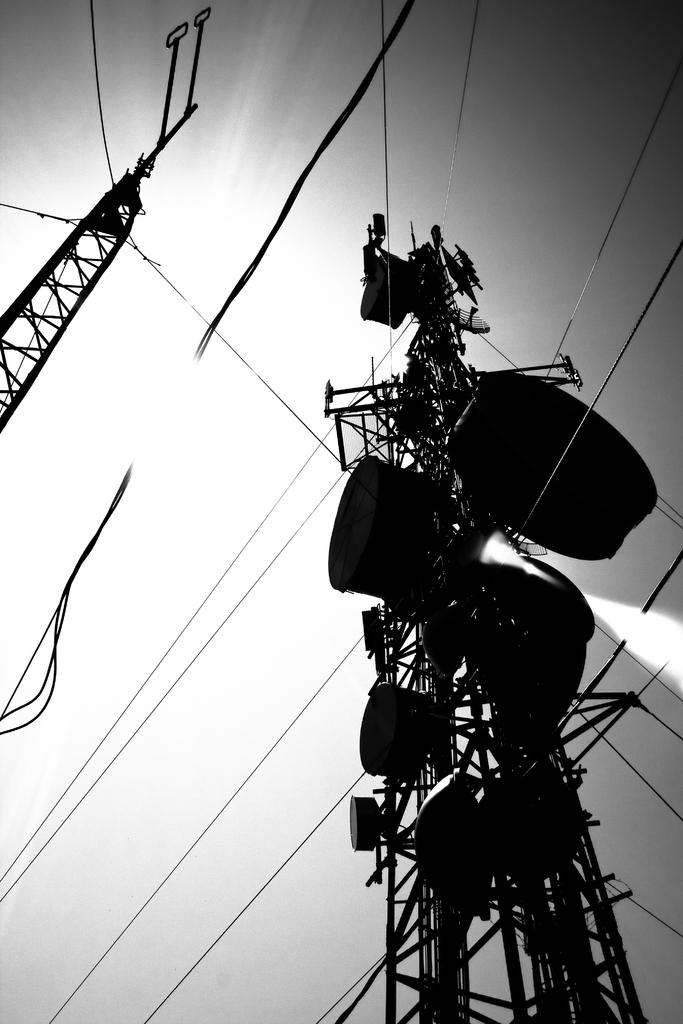What is the color scheme of the image? The image is black and white. How many towers can be seen in the image? There are two towers in the image. What else is visible in the image besides the towers? Wires are visible in the image. What can be seen in the background of the image? The sky is visible in the background of the image. Where are the pigs located in the image? There are no pigs present in the image. What type of hospital is depicted in the image? There is no hospital depicted in the image. 